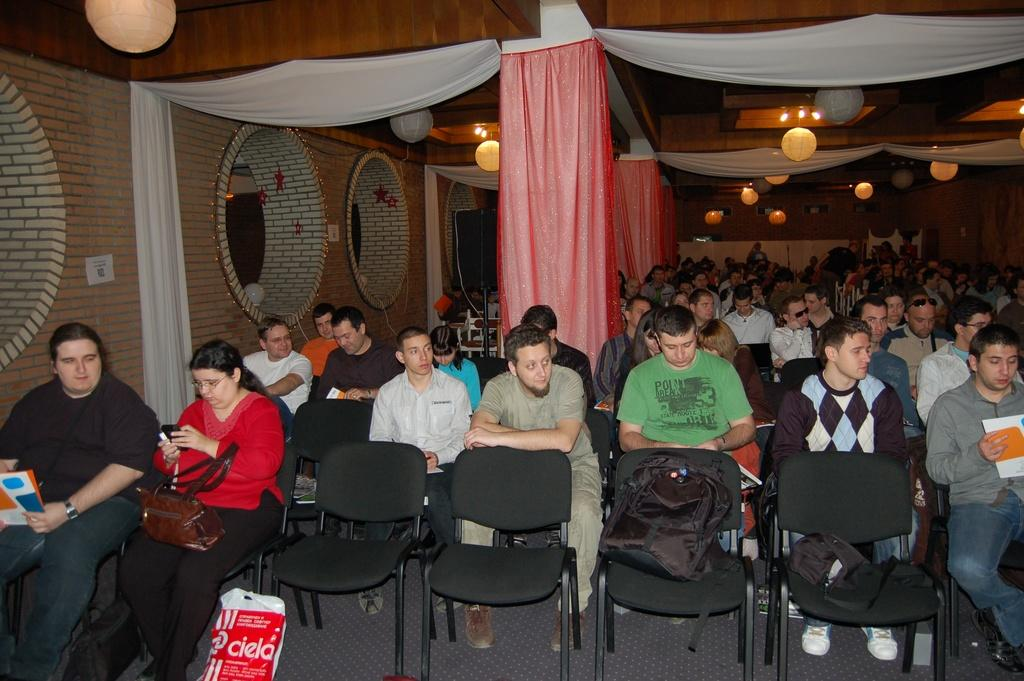What type of bird is in the image? There is a crow in the image. Where is the crow sitting? The crow is sitting on chairs. What can be seen in the background of the image? There is a wall, pillars, curtains, and lights in the background of the image. What type of location might the image have been taken in? The image may have been taken in a hall. What type of decision is the crow making in the image? The image does not depict the crow making a decision; it simply shows the crow sitting on chairs. Can you tell me what kind of flower is present in the image? There are no flowers present in the image. 